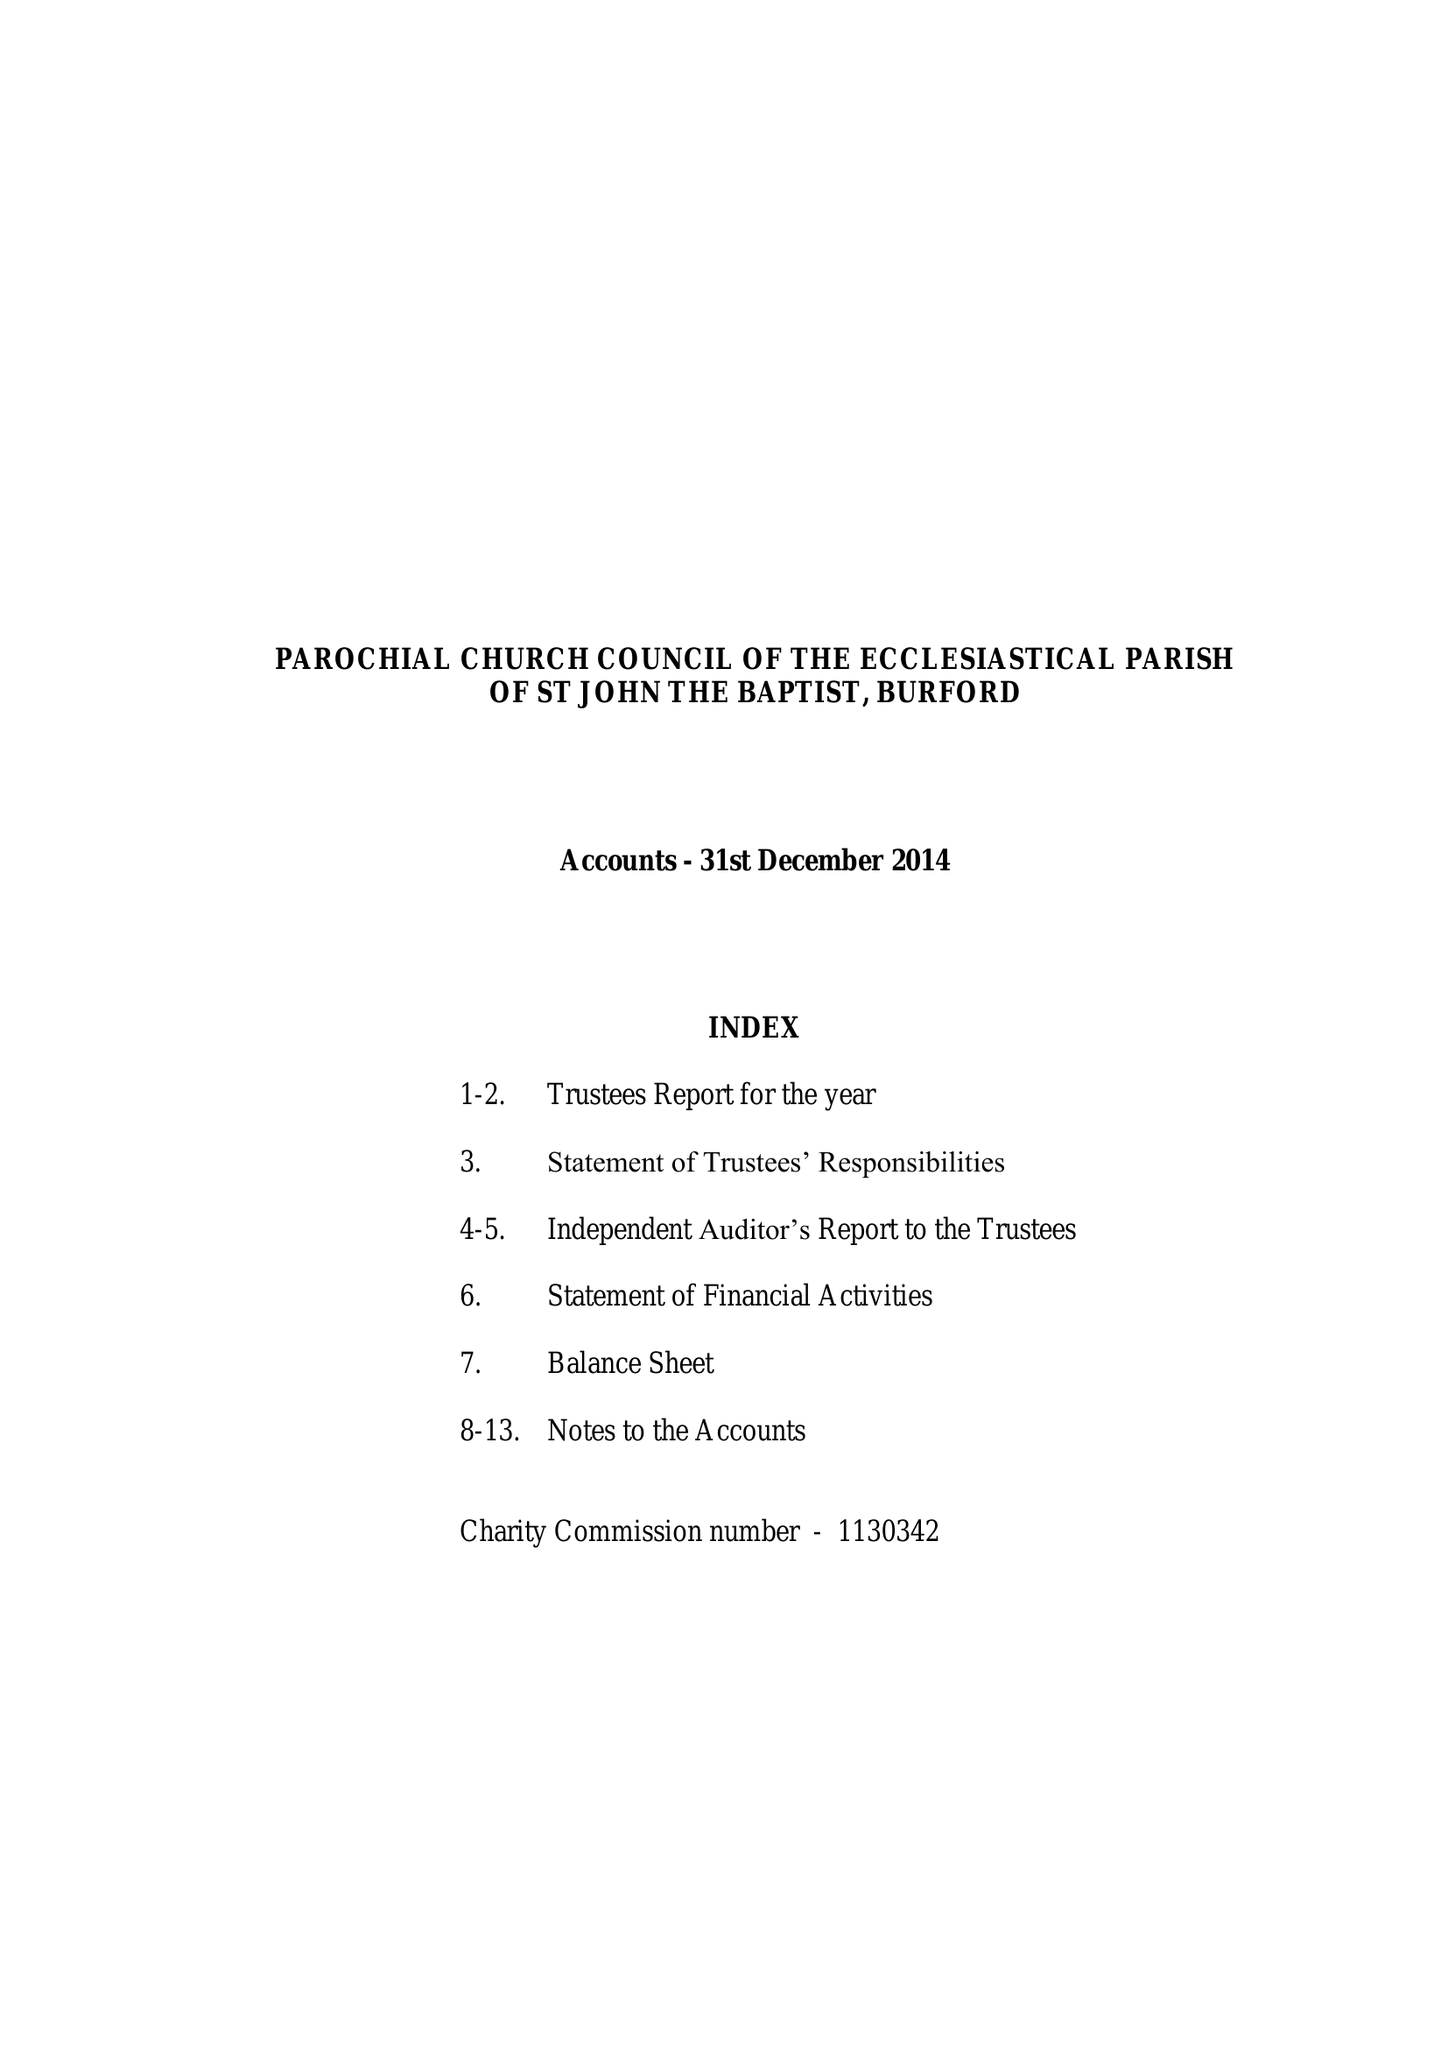What is the value for the address__post_town?
Answer the question using a single word or phrase. CARTERTON 